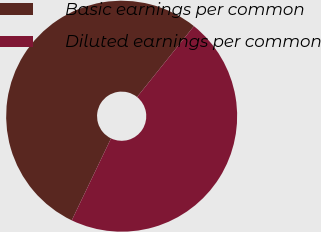<chart> <loc_0><loc_0><loc_500><loc_500><pie_chart><fcel>Basic earnings per common<fcel>Diluted earnings per common<nl><fcel>53.65%<fcel>46.35%<nl></chart> 